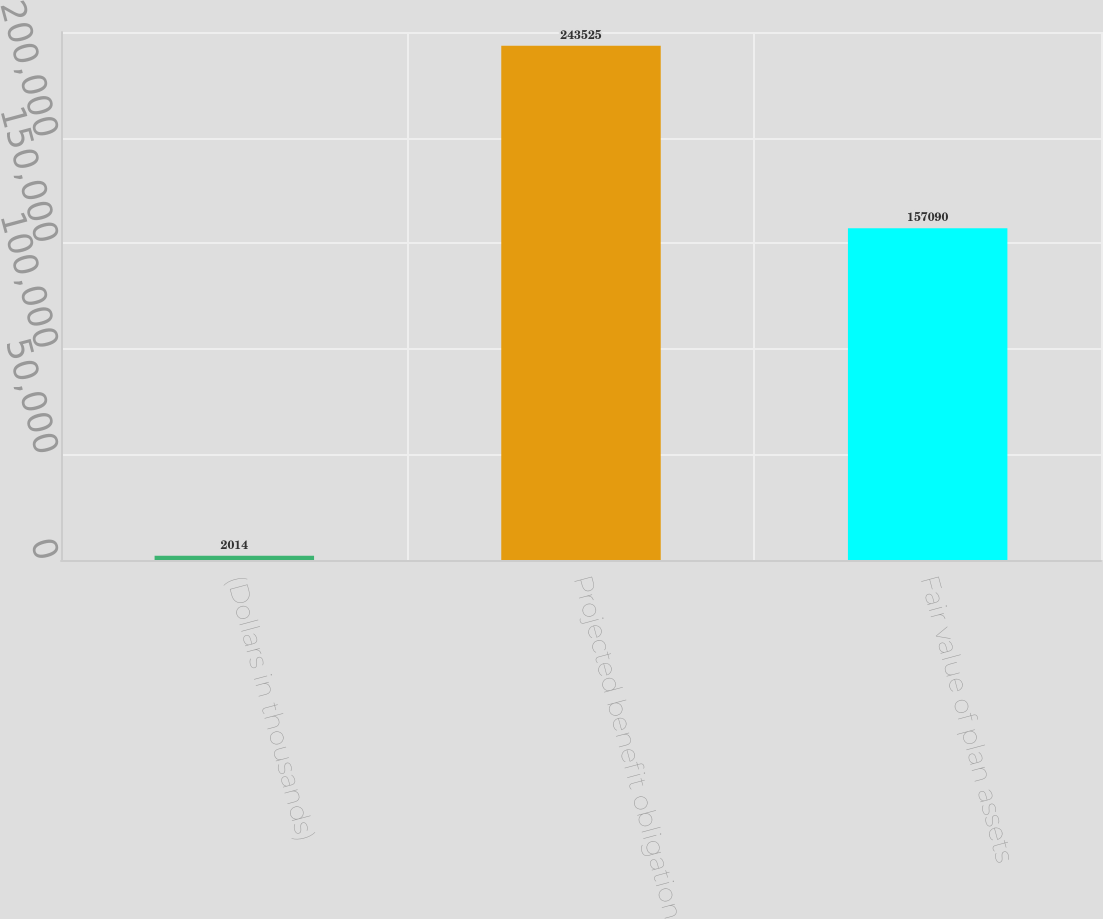Convert chart. <chart><loc_0><loc_0><loc_500><loc_500><bar_chart><fcel>(Dollars in thousands)<fcel>Projected benefit obligation<fcel>Fair value of plan assets<nl><fcel>2014<fcel>243525<fcel>157090<nl></chart> 